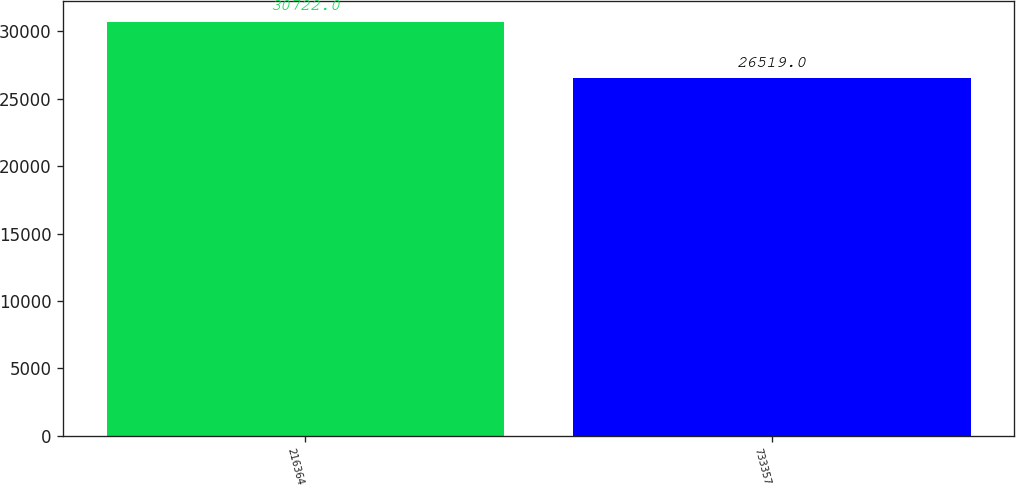Convert chart to OTSL. <chart><loc_0><loc_0><loc_500><loc_500><bar_chart><fcel>216364<fcel>733357<nl><fcel>30722<fcel>26519<nl></chart> 